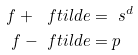Convert formula to latex. <formula><loc_0><loc_0><loc_500><loc_500>f + \ f t i l d e & = \ s ^ { d } \\ f - \ f t i l d e & = p</formula> 